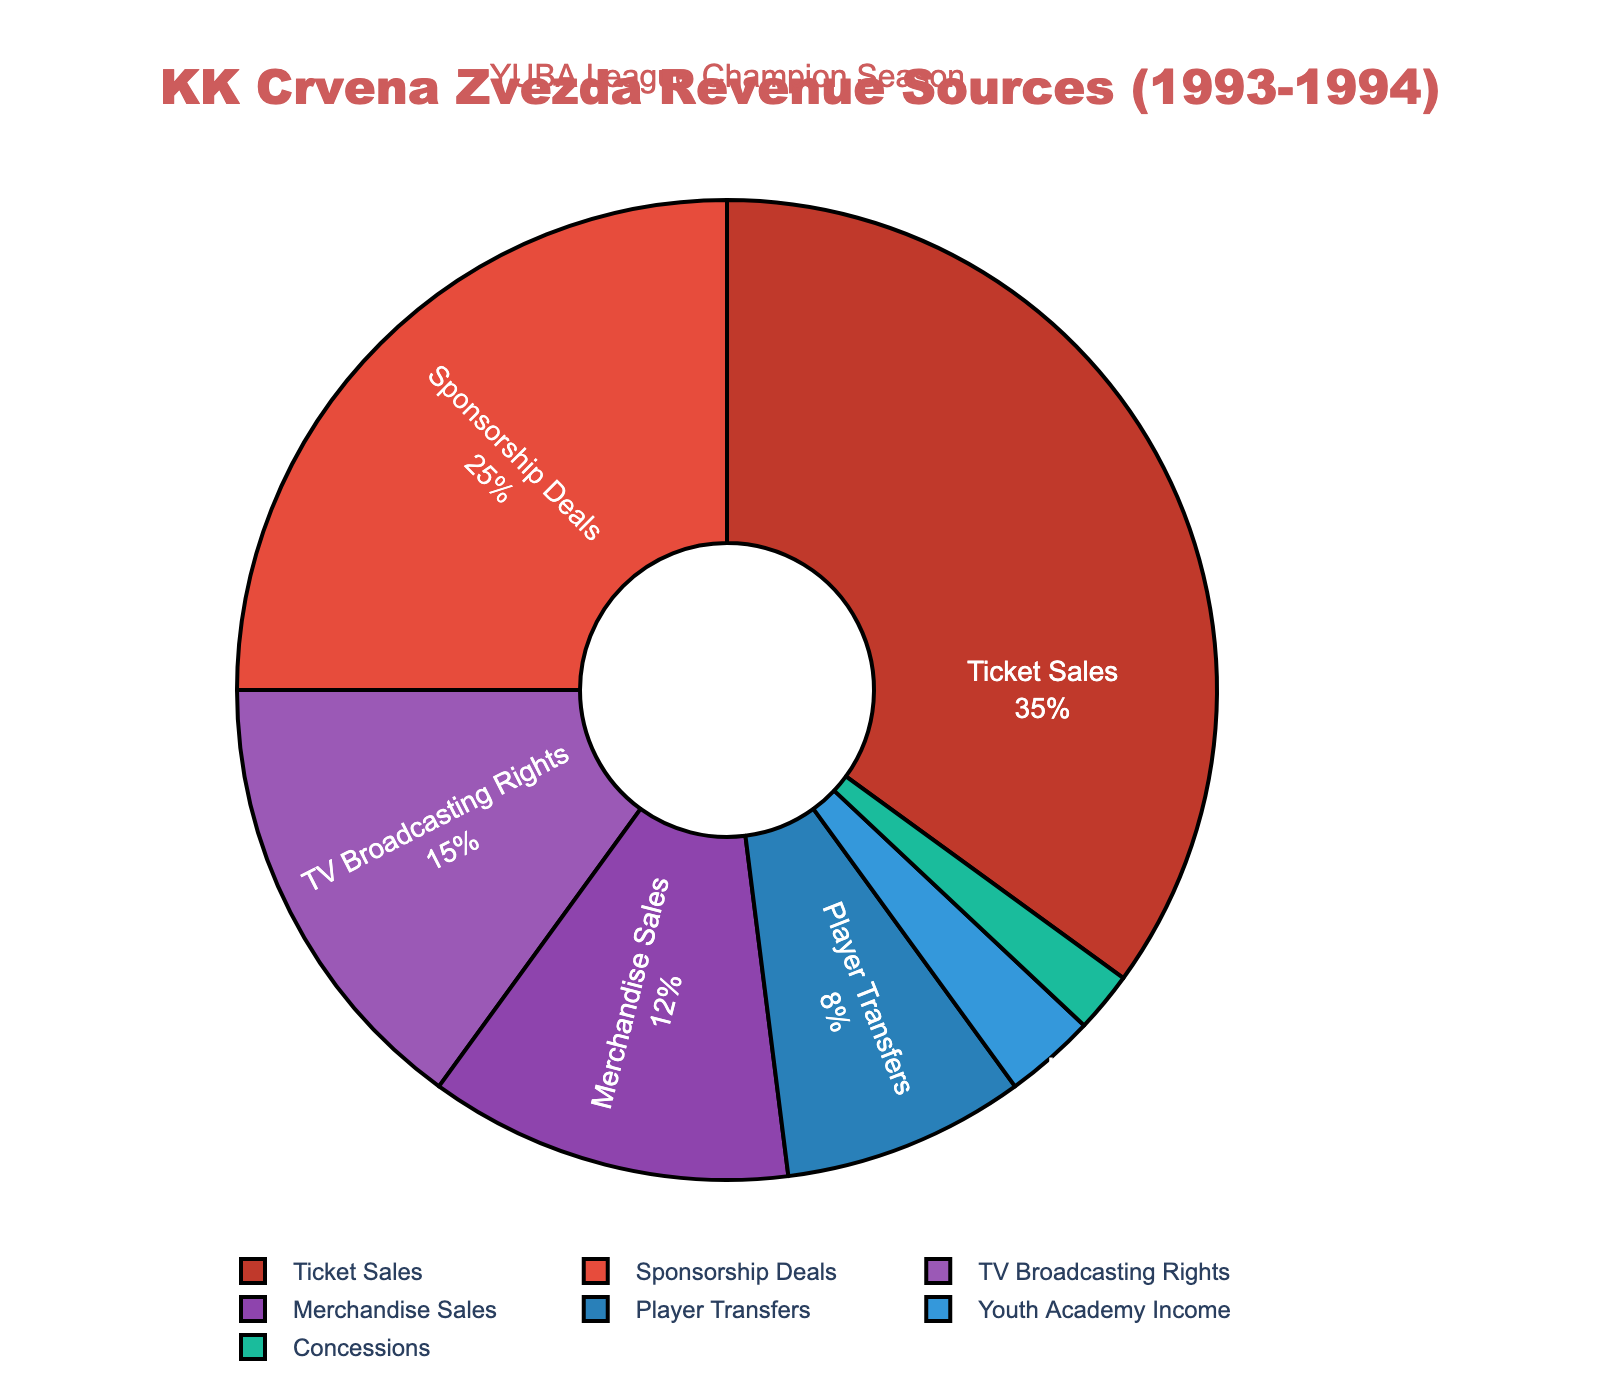What was the largest revenue source for KK Crvena Zvezda during the 1993-1994 season? The largest slice in the pie chart is labeled "Ticket Sales" with 35%, indicating that this was the biggest revenue source.
Answer: Ticket Sales How much more did KK Crvena Zvezda make from ticket sales compared to merchandise sales? The pie chart shows ticket sales at 35% and merchandise sales at 12%. The difference is 35% - 12% = 23%.
Answer: 23% Which revenue source contributed the least to KK Crvena Zvezda’s total revenue? The smallest slice in the pie chart is labeled "Concessions" with 2%, indicating it contributed the least.
Answer: Concessions What is the combined percentage of revenue from sponsorship deals and TV broadcasting rights? The pie chart indicates that sponsorship deals account for 25% and TV broadcasting rights account for 15%. Their combined percentage is 25% + 15% = 40%.
Answer: 40% Out of the presented revenue sources, how many contributed less than 10% to the total revenue? In the pie chart, the slices labeled "Player Transfers" (8%), "Youth Academy Income" (3%), and "Concessions" (2%) are all less than 10%. Thus, there are 3 such sources.
Answer: 3 Which revenue source is represented by the color gold (between yellow and orange) in the pie chart? The pie chart uses colors logically associated, and considering common color-coding, TV Broadcasting Rights is likely to be represented by gold. However, without seeing the chart, we match the smallest segments accordingly with standard schemes and confirm "Youth Academy Income" might use less prominent color shades.
Answer: Youth Academy Income What is the difference between the revenue percentages of the top two sources? The top two revenue sources are Ticket Sales (35%) and Sponsorship Deals (25%). The difference between them is 35% - 25% = 10%.
Answer: 10% What is the average revenue percentage of player transfers, youth academy income, and concessions combined? Adding percentages of player transfers (8%), youth academy income (3%), and concessions (2%) gives 8% + 3% + 2% = 13%. Dividing by 3: 13% / 3 ≈ 4.33%.
Answer: 4.33% Between merchandise sales and TV broadcasting rights, which provided a greater revenue percentage, and by how much? The pie chart shows merchandise sales at 12% and TV broadcasting rights at 15%. TV broadcasting rights provided a greater percentage by 3%, because 15% - 12% = 3%.
Answer: TV broadcasting rights by 3% 